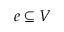Convert formula to latex. <formula><loc_0><loc_0><loc_500><loc_500>e \subseteq V</formula> 